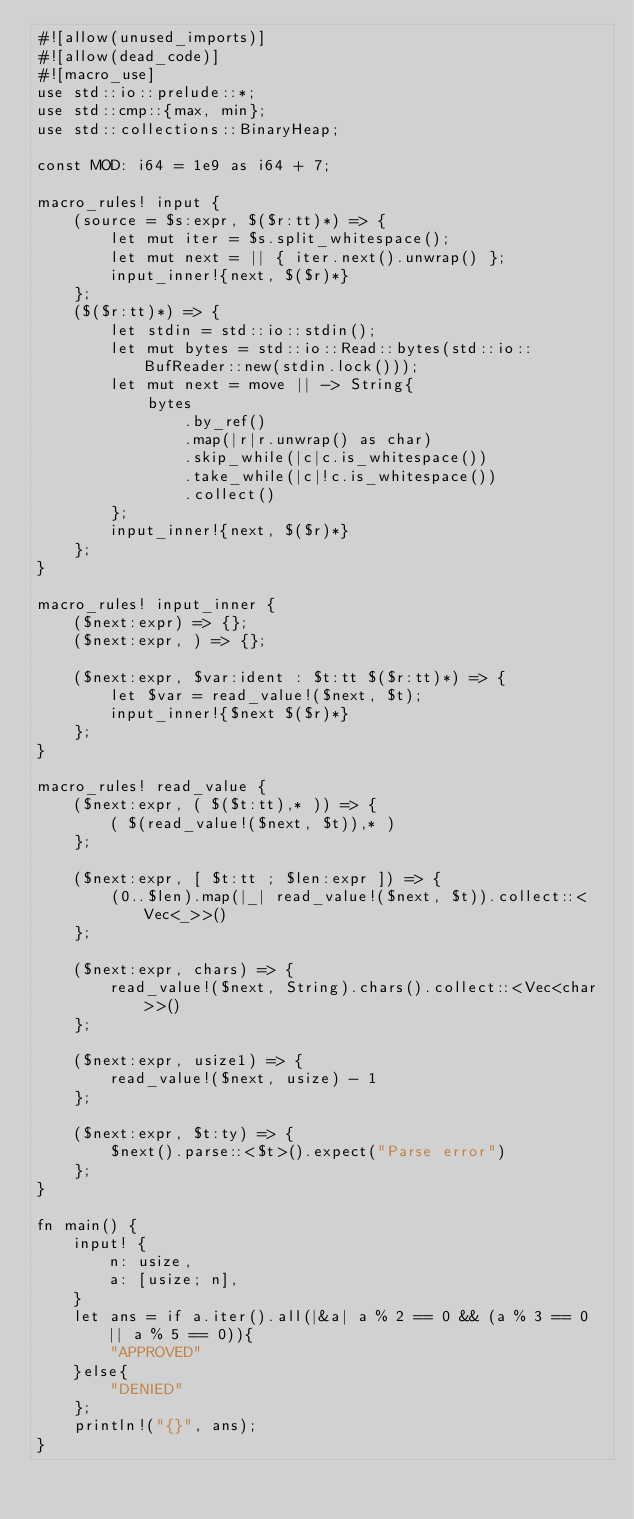<code> <loc_0><loc_0><loc_500><loc_500><_Rust_>#![allow(unused_imports)]
#![allow(dead_code)]
#![macro_use]
use std::io::prelude::*;
use std::cmp::{max, min};
use std::collections::BinaryHeap;

const MOD: i64 = 1e9 as i64 + 7;

macro_rules! input {
    (source = $s:expr, $($r:tt)*) => {
        let mut iter = $s.split_whitespace();
        let mut next = || { iter.next().unwrap() };
        input_inner!{next, $($r)*}
    };
    ($($r:tt)*) => {
        let stdin = std::io::stdin();
        let mut bytes = std::io::Read::bytes(std::io::BufReader::new(stdin.lock()));
        let mut next = move || -> String{
            bytes
                .by_ref()
                .map(|r|r.unwrap() as char)
                .skip_while(|c|c.is_whitespace())
                .take_while(|c|!c.is_whitespace())
                .collect()
        };
        input_inner!{next, $($r)*}
    };
}

macro_rules! input_inner {
    ($next:expr) => {};
    ($next:expr, ) => {};

    ($next:expr, $var:ident : $t:tt $($r:tt)*) => {
        let $var = read_value!($next, $t);
        input_inner!{$next $($r)*}
    };
}

macro_rules! read_value {
    ($next:expr, ( $($t:tt),* )) => {
        ( $(read_value!($next, $t)),* )
    };

    ($next:expr, [ $t:tt ; $len:expr ]) => {
        (0..$len).map(|_| read_value!($next, $t)).collect::<Vec<_>>()
    };

    ($next:expr, chars) => {
        read_value!($next, String).chars().collect::<Vec<char>>()
    };

    ($next:expr, usize1) => {
        read_value!($next, usize) - 1
    };

    ($next:expr, $t:ty) => {
        $next().parse::<$t>().expect("Parse error")
    };
}

fn main() {
    input! {
        n: usize,
        a: [usize; n],
    }
    let ans = if a.iter().all(|&a| a % 2 == 0 && (a % 3 == 0 || a % 5 == 0)){
        "APPROVED"
    }else{
        "DENIED"
    };
    println!("{}", ans);
}
</code> 